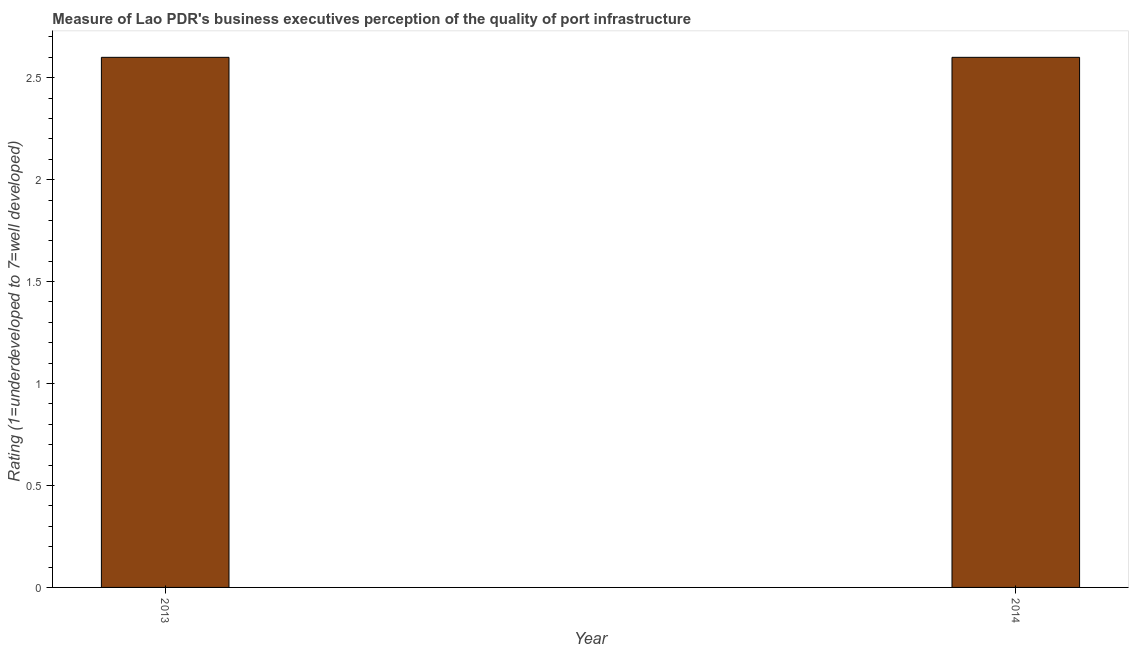Does the graph contain grids?
Ensure brevity in your answer.  No. What is the title of the graph?
Provide a short and direct response. Measure of Lao PDR's business executives perception of the quality of port infrastructure. What is the label or title of the Y-axis?
Offer a very short reply. Rating (1=underdeveloped to 7=well developed) . What is the rating measuring quality of port infrastructure in 2013?
Provide a short and direct response. 2.6. Across all years, what is the maximum rating measuring quality of port infrastructure?
Offer a terse response. 2.6. Across all years, what is the minimum rating measuring quality of port infrastructure?
Your response must be concise. 2.6. In which year was the rating measuring quality of port infrastructure minimum?
Provide a short and direct response. 2013. What is the sum of the rating measuring quality of port infrastructure?
Keep it short and to the point. 5.2. What is the difference between the rating measuring quality of port infrastructure in 2013 and 2014?
Keep it short and to the point. 0. In how many years, is the rating measuring quality of port infrastructure greater than 0.8 ?
Keep it short and to the point. 2. Do a majority of the years between 2014 and 2013 (inclusive) have rating measuring quality of port infrastructure greater than 2.1 ?
Make the answer very short. No. Is the rating measuring quality of port infrastructure in 2013 less than that in 2014?
Give a very brief answer. No. What is the difference between two consecutive major ticks on the Y-axis?
Your answer should be very brief. 0.5. Are the values on the major ticks of Y-axis written in scientific E-notation?
Make the answer very short. No. What is the Rating (1=underdeveloped to 7=well developed)  of 2013?
Your answer should be very brief. 2.6. What is the Rating (1=underdeveloped to 7=well developed)  in 2014?
Give a very brief answer. 2.6. What is the ratio of the Rating (1=underdeveloped to 7=well developed)  in 2013 to that in 2014?
Provide a short and direct response. 1. 